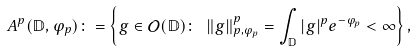Convert formula to latex. <formula><loc_0><loc_0><loc_500><loc_500>A ^ { p } ( \mathbb { D } , \varphi _ { p } ) \colon = \left \{ g \in \mathcal { O } ( \mathbb { D } ) \colon \ \| g \| _ { p , \varphi _ { p } } ^ { p } = \int _ { \mathbb { D } } | g | ^ { p } e ^ { - \varphi _ { p } } < \infty \right \} ,</formula> 